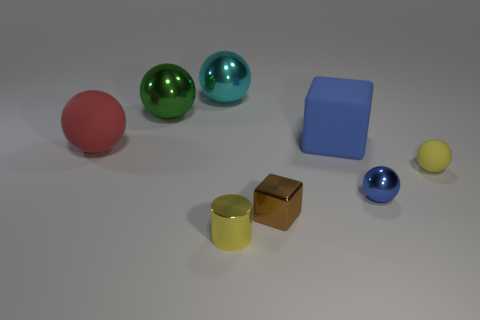What is the color of the metal thing that is behind the tiny brown object and on the right side of the tiny yellow metallic object?
Give a very brief answer. Blue. Are there any large cyan shiny objects to the right of the small blue metallic sphere?
Give a very brief answer. No. There is a yellow object that is right of the big cube; how many balls are behind it?
Keep it short and to the point. 3. What is the size of the blue sphere that is made of the same material as the brown block?
Give a very brief answer. Small. What size is the red rubber sphere?
Offer a terse response. Large. Is the big cube made of the same material as the small cylinder?
Offer a terse response. No. How many cubes are either large blue matte objects or tiny brown shiny objects?
Provide a succinct answer. 2. What color is the metallic object to the right of the big rubber object that is behind the big red object?
Your answer should be very brief. Blue. There is a metallic thing that is the same color as the small rubber sphere; what is its size?
Make the answer very short. Small. How many shiny things are behind the blue object in front of the big matte object that is left of the green object?
Your answer should be compact. 2. 